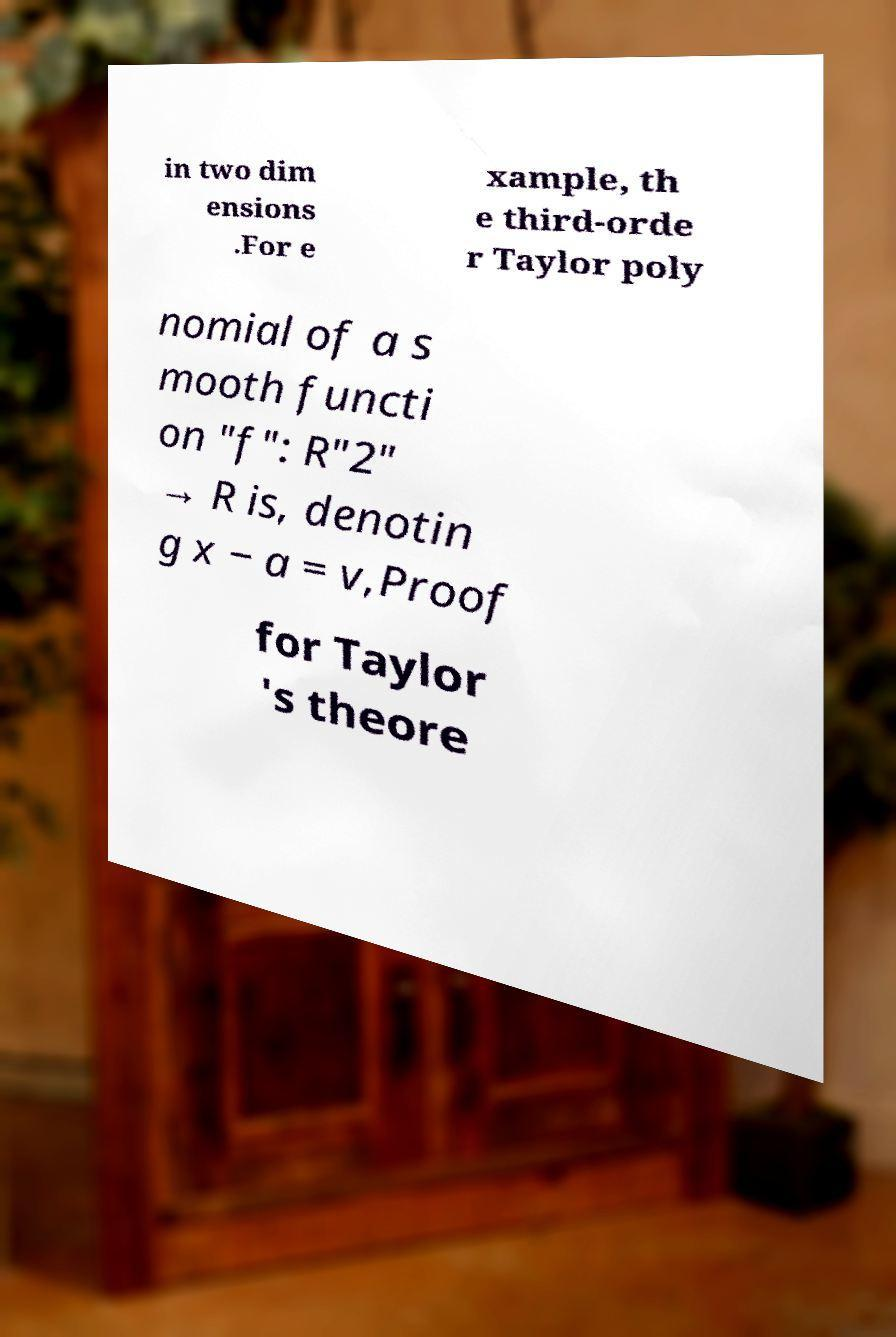For documentation purposes, I need the text within this image transcribed. Could you provide that? in two dim ensions .For e xample, th e third-orde r Taylor poly nomial of a s mooth functi on "f": R"2" → R is, denotin g x − a = v,Proof for Taylor 's theore 